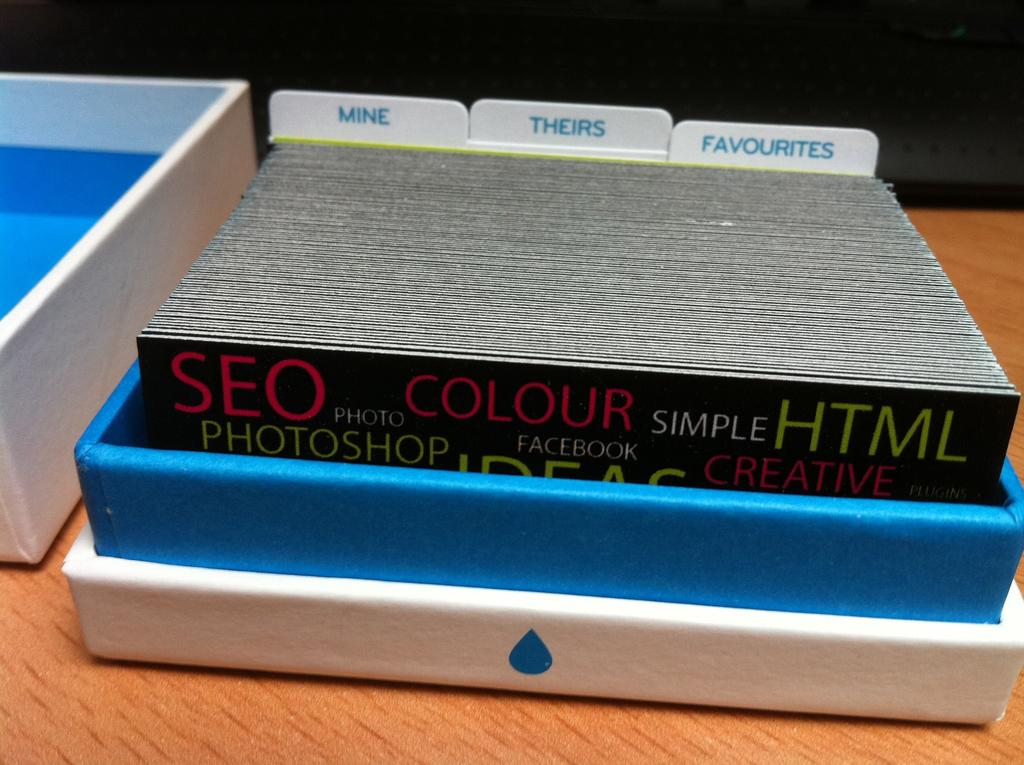<image>
Summarize the visual content of the image. A shallow box contains tabs for mine, theirs and favorites. 